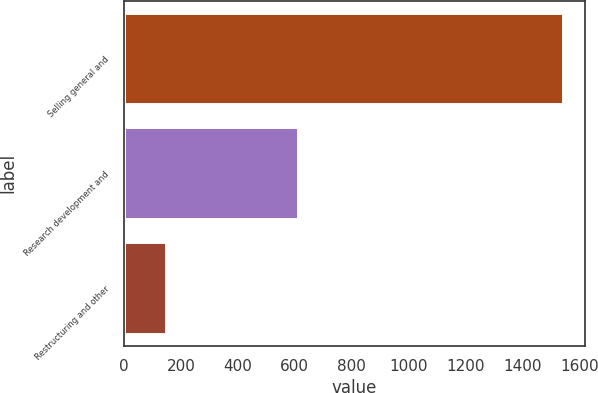Convert chart to OTSL. <chart><loc_0><loc_0><loc_500><loc_500><bar_chart><fcel>Selling general and<fcel>Research development and<fcel>Restructuring and other<nl><fcel>1543<fcel>611<fcel>147<nl></chart> 